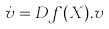<formula> <loc_0><loc_0><loc_500><loc_500>\dot { v } = D f ( X ) . v</formula> 